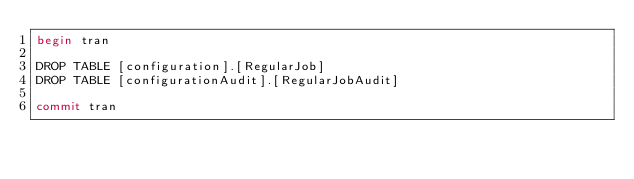Convert code to text. <code><loc_0><loc_0><loc_500><loc_500><_SQL_>begin tran

DROP TABLE [configuration].[RegularJob]
DROP TABLE [configurationAudit].[RegularJobAudit]

commit tran</code> 